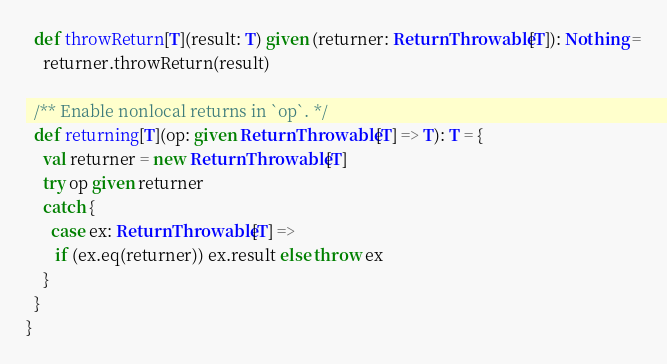<code> <loc_0><loc_0><loc_500><loc_500><_Scala_>  def throwReturn[T](result: T) given (returner: ReturnThrowable[T]): Nothing =
    returner.throwReturn(result)

  /** Enable nonlocal returns in `op`. */
  def returning[T](op: given ReturnThrowable[T] => T): T = {
    val returner = new ReturnThrowable[T]
    try op given returner
    catch {
      case ex: ReturnThrowable[T] =>
       if (ex.eq(returner)) ex.result else throw ex
    }
  }
}
</code> 